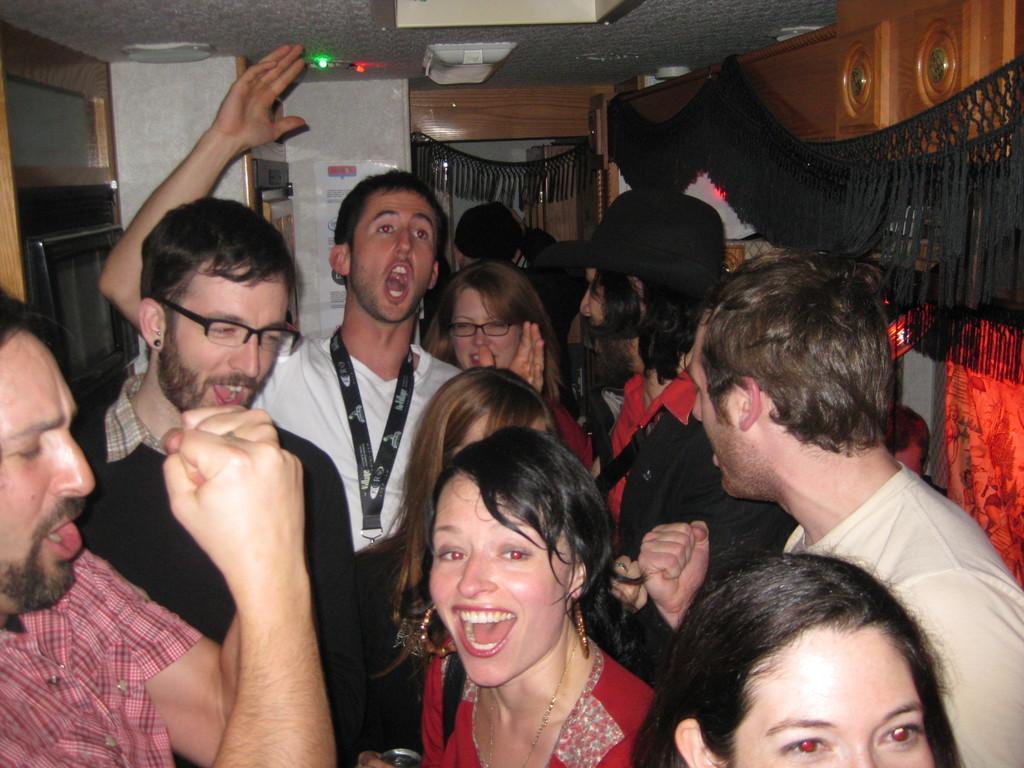In one or two sentences, can you explain what this image depicts? In this image we can see a group of people standing in a room, there is a black color cloth hanged to the wall, there is a light to the ceiling and there is a television on the shelf. 